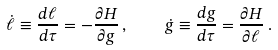Convert formula to latex. <formula><loc_0><loc_0><loc_500><loc_500>\dot { \ell } \equiv \frac { d \ell } { d \tau } = - \frac { \partial H } { \partial g } \, , \quad \dot { g } \equiv \frac { d g } { d \tau } = \frac { \partial H } { \partial \ell } \, .</formula> 